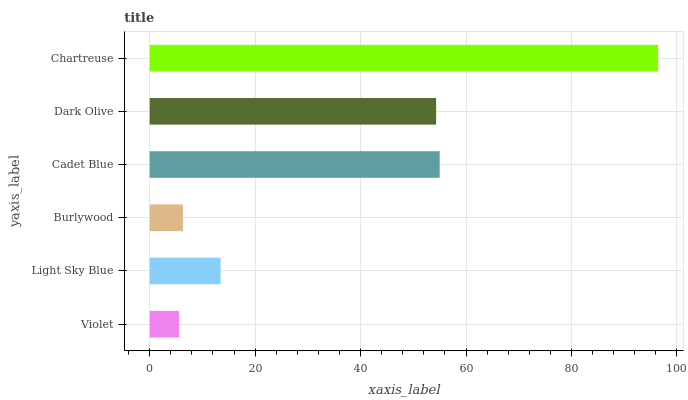Is Violet the minimum?
Answer yes or no. Yes. Is Chartreuse the maximum?
Answer yes or no. Yes. Is Light Sky Blue the minimum?
Answer yes or no. No. Is Light Sky Blue the maximum?
Answer yes or no. No. Is Light Sky Blue greater than Violet?
Answer yes or no. Yes. Is Violet less than Light Sky Blue?
Answer yes or no. Yes. Is Violet greater than Light Sky Blue?
Answer yes or no. No. Is Light Sky Blue less than Violet?
Answer yes or no. No. Is Dark Olive the high median?
Answer yes or no. Yes. Is Light Sky Blue the low median?
Answer yes or no. Yes. Is Violet the high median?
Answer yes or no. No. Is Violet the low median?
Answer yes or no. No. 